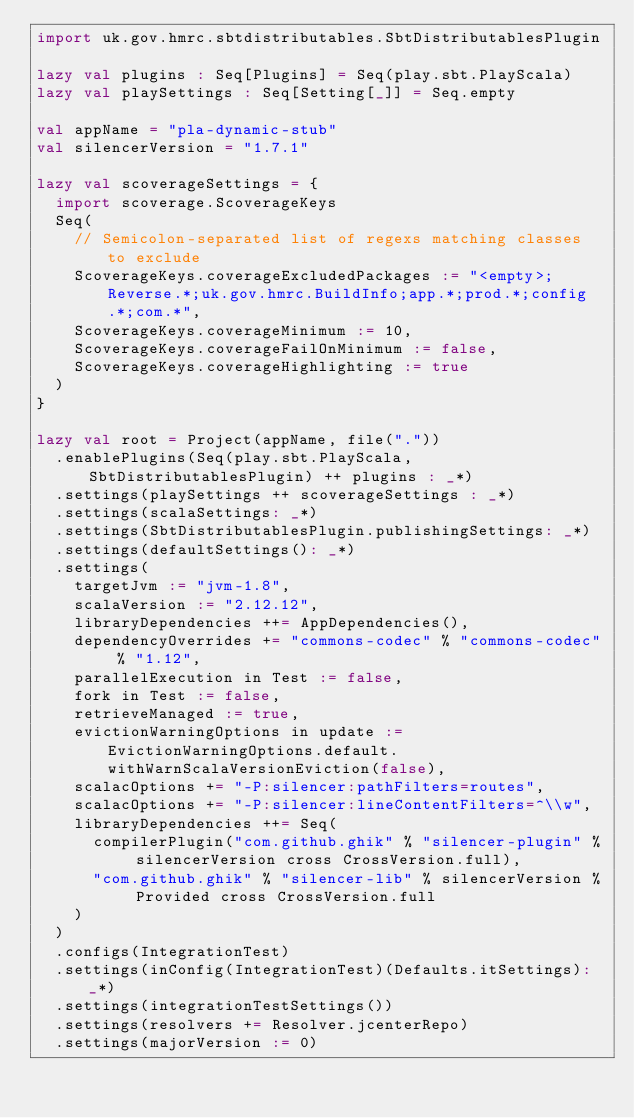Convert code to text. <code><loc_0><loc_0><loc_500><loc_500><_Scala_>import uk.gov.hmrc.sbtdistributables.SbtDistributablesPlugin

lazy val plugins : Seq[Plugins] = Seq(play.sbt.PlayScala)
lazy val playSettings : Seq[Setting[_]] = Seq.empty

val appName = "pla-dynamic-stub"
val silencerVersion = "1.7.1"

lazy val scoverageSettings = {
  import scoverage.ScoverageKeys
  Seq(
    // Semicolon-separated list of regexs matching classes to exclude
    ScoverageKeys.coverageExcludedPackages := "<empty>;Reverse.*;uk.gov.hmrc.BuildInfo;app.*;prod.*;config.*;com.*",
    ScoverageKeys.coverageMinimum := 10,
    ScoverageKeys.coverageFailOnMinimum := false,
    ScoverageKeys.coverageHighlighting := true
  )
}

lazy val root = Project(appName, file("."))
  .enablePlugins(Seq(play.sbt.PlayScala, SbtDistributablesPlugin) ++ plugins : _*)
  .settings(playSettings ++ scoverageSettings : _*)
  .settings(scalaSettings: _*)
  .settings(SbtDistributablesPlugin.publishingSettings: _*)
  .settings(defaultSettings(): _*)
  .settings(
    targetJvm := "jvm-1.8",
    scalaVersion := "2.12.12",
    libraryDependencies ++= AppDependencies(),
    dependencyOverrides += "commons-codec" % "commons-codec" % "1.12",
    parallelExecution in Test := false,
    fork in Test := false,
    retrieveManaged := true,
    evictionWarningOptions in update := EvictionWarningOptions.default.withWarnScalaVersionEviction(false),
    scalacOptions += "-P:silencer:pathFilters=routes",
    scalacOptions += "-P:silencer:lineContentFilters=^\\w",
    libraryDependencies ++= Seq(
      compilerPlugin("com.github.ghik" % "silencer-plugin" % silencerVersion cross CrossVersion.full),
      "com.github.ghik" % "silencer-lib" % silencerVersion % Provided cross CrossVersion.full
    )
  )
  .configs(IntegrationTest)
  .settings(inConfig(IntegrationTest)(Defaults.itSettings): _*)
  .settings(integrationTestSettings())
  .settings(resolvers += Resolver.jcenterRepo)
  .settings(majorVersion := 0)
</code> 